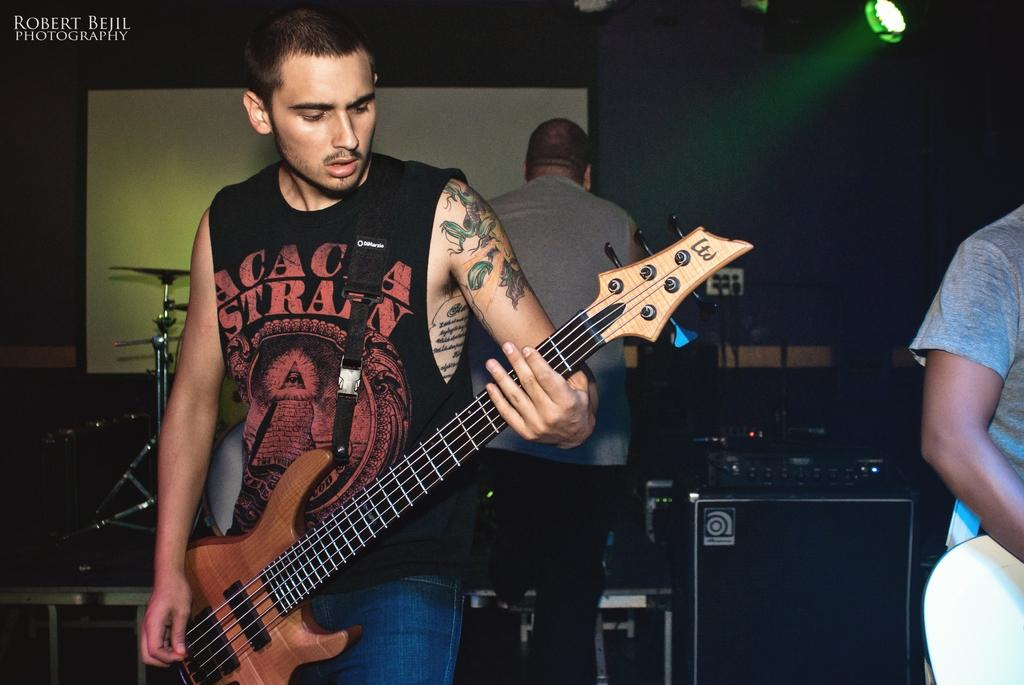How many people are in the image? There are three people in the image. Where are the people located in the image? The people are on the left side of the image. What is the man doing in the image? The man is playing a guitar. What else can be seen in the background of the image? There are musical instruments and light visible in the background. What type of cave can be seen in the background of the image? There is no cave present in the image; it features three people, a guitar-playing man, and musical instruments in the background. 